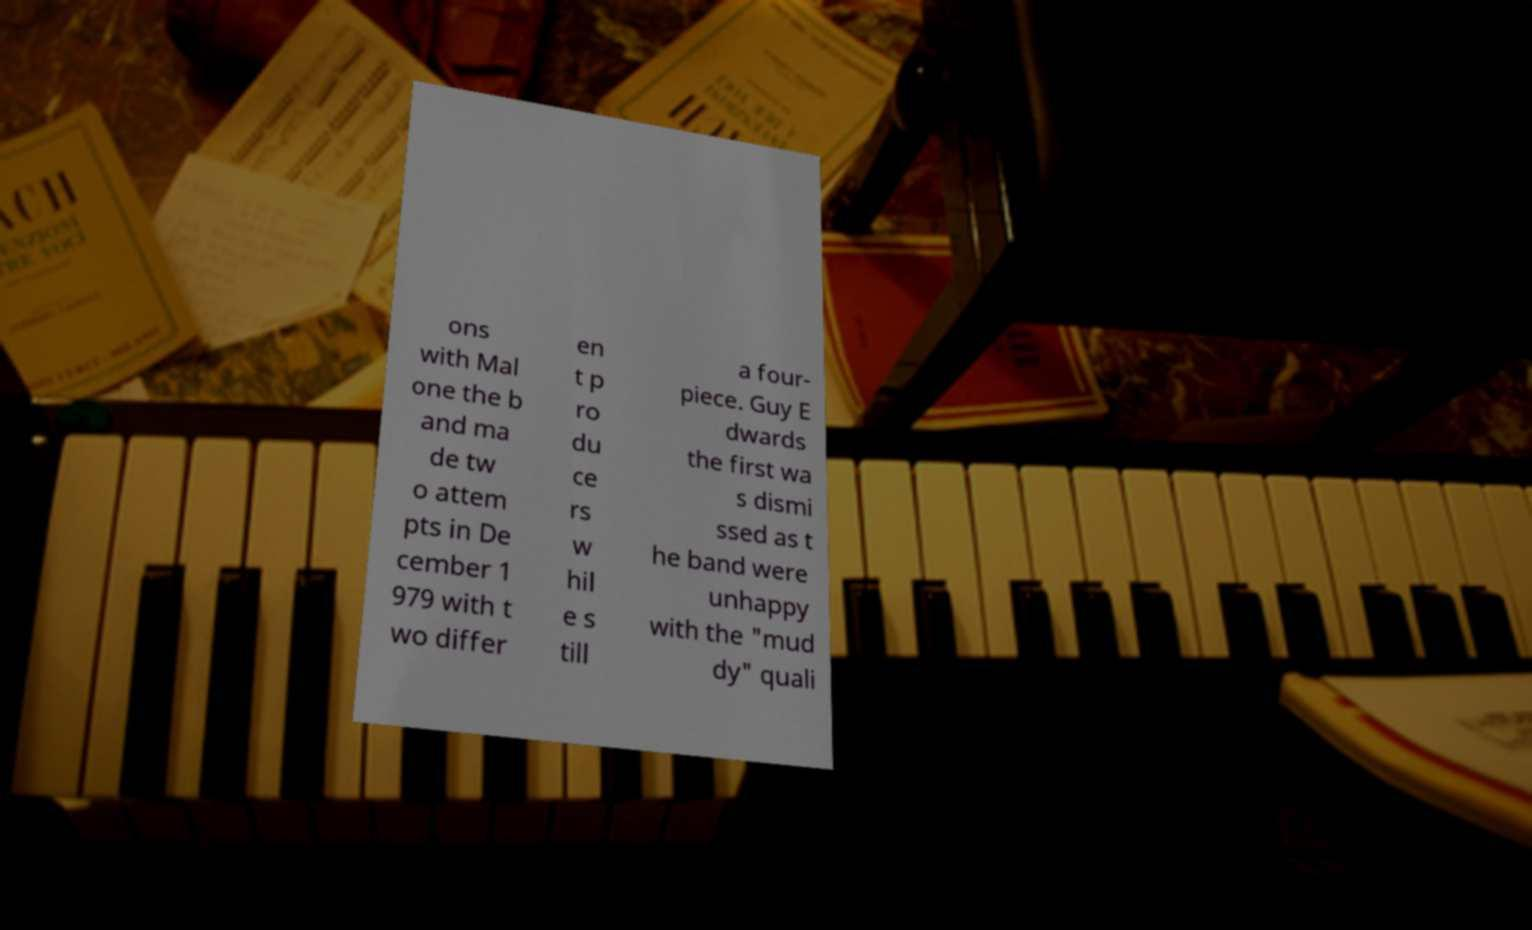Can you accurately transcribe the text from the provided image for me? ons with Mal one the b and ma de tw o attem pts in De cember 1 979 with t wo differ en t p ro du ce rs w hil e s till a four- piece. Guy E dwards the first wa s dismi ssed as t he band were unhappy with the "mud dy" quali 